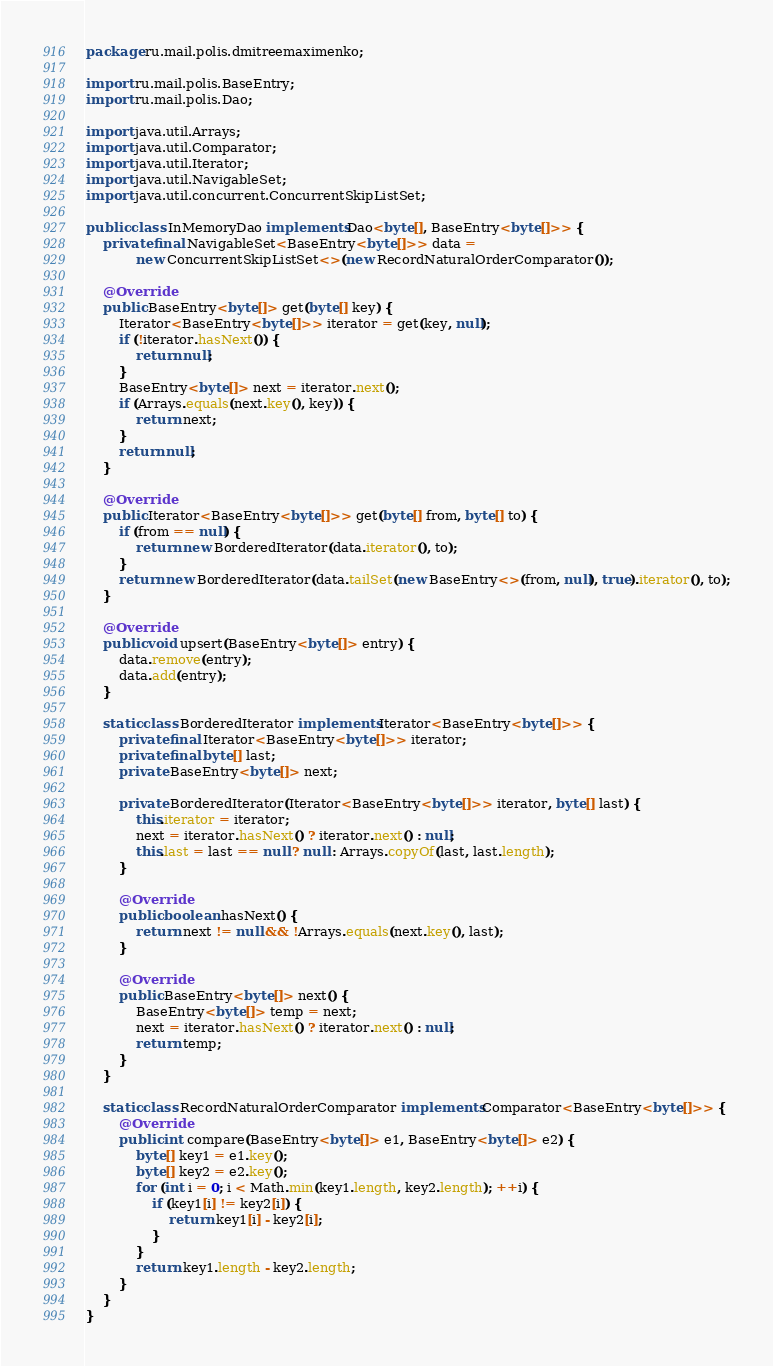<code> <loc_0><loc_0><loc_500><loc_500><_Java_>package ru.mail.polis.dmitreemaximenko;

import ru.mail.polis.BaseEntry;
import ru.mail.polis.Dao;

import java.util.Arrays;
import java.util.Comparator;
import java.util.Iterator;
import java.util.NavigableSet;
import java.util.concurrent.ConcurrentSkipListSet;

public class InMemoryDao implements Dao<byte[], BaseEntry<byte[]>> {
    private final NavigableSet<BaseEntry<byte[]>> data =
            new ConcurrentSkipListSet<>(new RecordNaturalOrderComparator());

    @Override
    public BaseEntry<byte[]> get(byte[] key) {
        Iterator<BaseEntry<byte[]>> iterator = get(key, null);
        if (!iterator.hasNext()) {
            return null;
        }
        BaseEntry<byte[]> next = iterator.next();
        if (Arrays.equals(next.key(), key)) {
            return next;
        }
        return null;
    }

    @Override
    public Iterator<BaseEntry<byte[]>> get(byte[] from, byte[] to) {
        if (from == null) {
            return new BorderedIterator(data.iterator(), to);
        }
        return new BorderedIterator(data.tailSet(new BaseEntry<>(from, null), true).iterator(), to);
    }

    @Override
    public void upsert(BaseEntry<byte[]> entry) {
        data.remove(entry);
        data.add(entry);
    }

    static class BorderedIterator implements Iterator<BaseEntry<byte[]>> {
        private final Iterator<BaseEntry<byte[]>> iterator;
        private final byte[] last;
        private BaseEntry<byte[]> next;

        private BorderedIterator(Iterator<BaseEntry<byte[]>> iterator, byte[] last) {
            this.iterator = iterator;
            next = iterator.hasNext() ? iterator.next() : null;
            this.last = last == null ? null : Arrays.copyOf(last, last.length);
        }

        @Override
        public boolean hasNext() {
            return next != null && !Arrays.equals(next.key(), last);
        }

        @Override
        public BaseEntry<byte[]> next() {
            BaseEntry<byte[]> temp = next;
            next = iterator.hasNext() ? iterator.next() : null;
            return temp;
        }
    }

    static class RecordNaturalOrderComparator implements Comparator<BaseEntry<byte[]>> {
        @Override
        public int compare(BaseEntry<byte[]> e1, BaseEntry<byte[]> e2) {
            byte[] key1 = e1.key();
            byte[] key2 = e2.key();
            for (int i = 0; i < Math.min(key1.length, key2.length); ++i) {
                if (key1[i] != key2[i]) {
                    return key1[i] - key2[i];
                }
            }
            return key1.length - key2.length;
        }
    }
}
</code> 